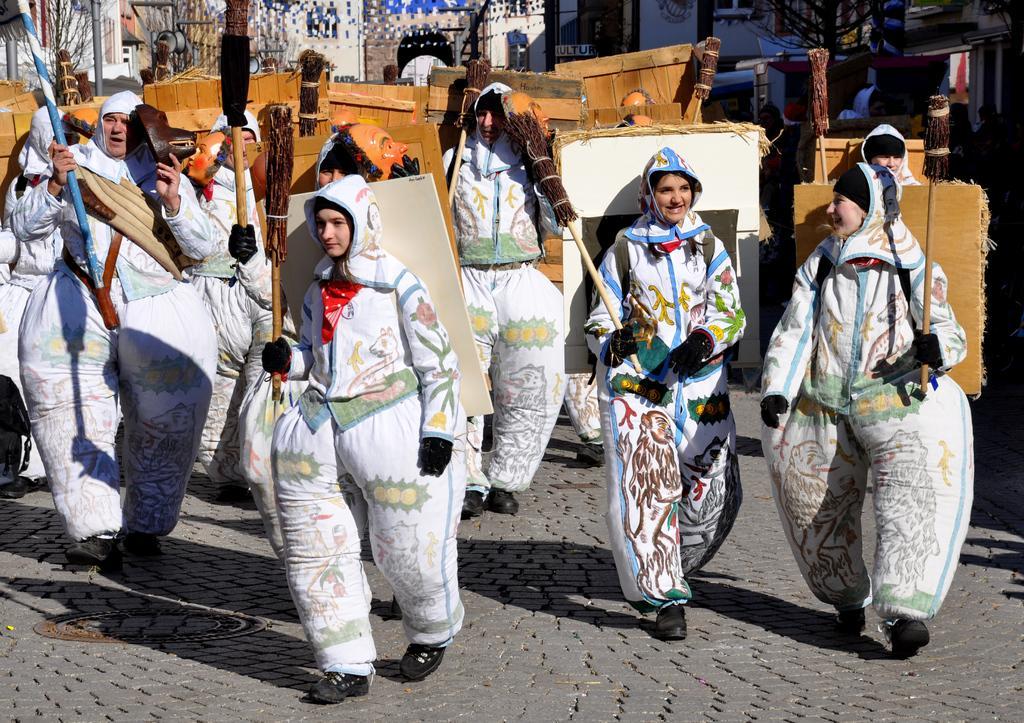Could you give a brief overview of what you see in this image? In this image I can see few people wearing costumes, holding sticks on their hands and walking on the road. In the background there are some buildings and trees. These people are wearing some sheets to their shoulders. 